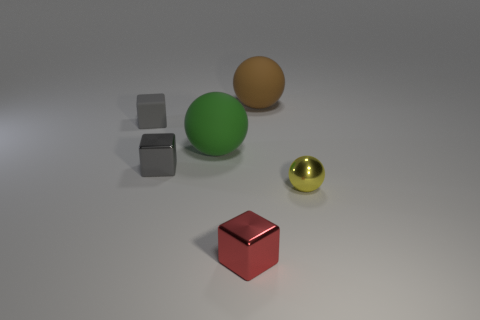There is a matte thing that is to the right of the tiny shiny block that is in front of the tiny metal block that is behind the yellow shiny thing; what size is it?
Your response must be concise. Large. Is the size of the green rubber ball the same as the brown sphere?
Offer a terse response. Yes. There is a tiny gray block that is to the right of the gray block that is left of the gray metal object; what is it made of?
Your answer should be compact. Metal. There is a tiny gray object on the right side of the gray matte thing; is it the same shape as the red metal thing in front of the big green thing?
Ensure brevity in your answer.  Yes. Are there the same number of tiny gray objects that are in front of the small matte block and small gray rubber cubes?
Your answer should be compact. Yes. There is a large rubber ball that is in front of the small gray rubber thing; are there any big matte objects behind it?
Give a very brief answer. Yes. Is there anything else that is the same color as the matte block?
Ensure brevity in your answer.  Yes. Is the big ball in front of the rubber block made of the same material as the large brown thing?
Your response must be concise. Yes. Is the number of gray matte cubes that are behind the big green sphere the same as the number of blocks that are to the left of the tiny red thing?
Ensure brevity in your answer.  No. How big is the gray block that is behind the large rubber sphere in front of the brown matte ball?
Offer a very short reply. Small. 